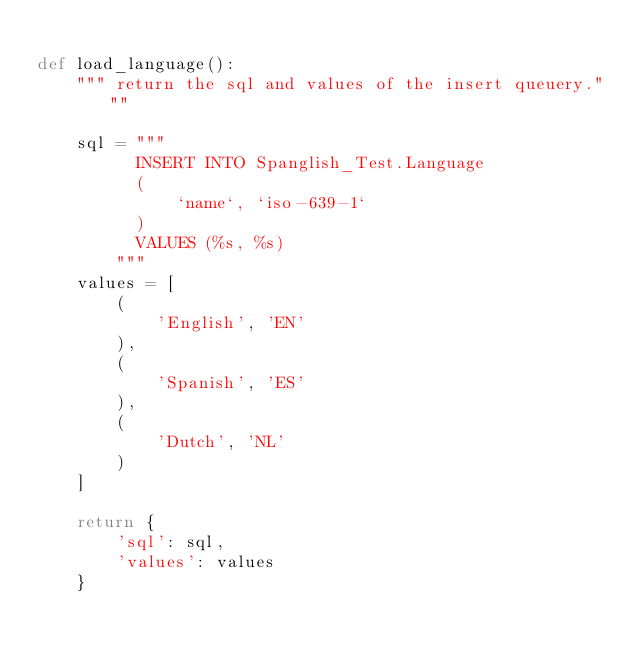<code> <loc_0><loc_0><loc_500><loc_500><_Python_>
def load_language():
    """ return the sql and values of the insert queuery."""

    sql = """
          INSERT INTO Spanglish_Test.Language 
          (
              `name`, `iso-639-1`
          ) 
          VALUES (%s, %s)
        """
    values = [
        (
            'English', 'EN'
        ),
        (
            'Spanish', 'ES'
        ),
        (
            'Dutch', 'NL'
        )
    ]

    return {
        'sql': sql, 
        'values': values
    }
</code> 